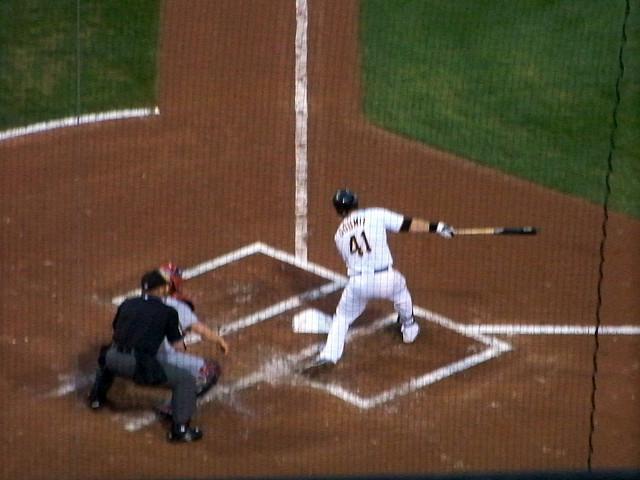How many people can be seen?
Give a very brief answer. 2. How many zebras are there?
Give a very brief answer. 0. 